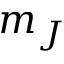Convert formula to latex. <formula><loc_0><loc_0><loc_500><loc_500>m _ { J }</formula> 